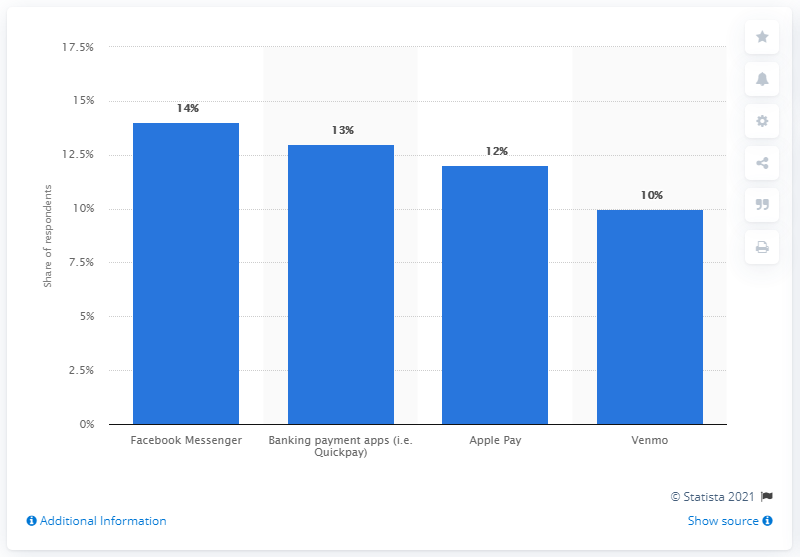Highlight a few significant elements in this photo. According to the survey, 14% of consumers reported using Facebook Messenger. 